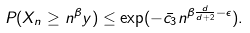Convert formula to latex. <formula><loc_0><loc_0><loc_500><loc_500>P ( X _ { n } \geq n ^ { \beta } y ) \leq \exp ( - \bar { c _ { 3 } } n ^ { \beta \frac { d } { d + 2 } - \epsilon } ) .</formula> 